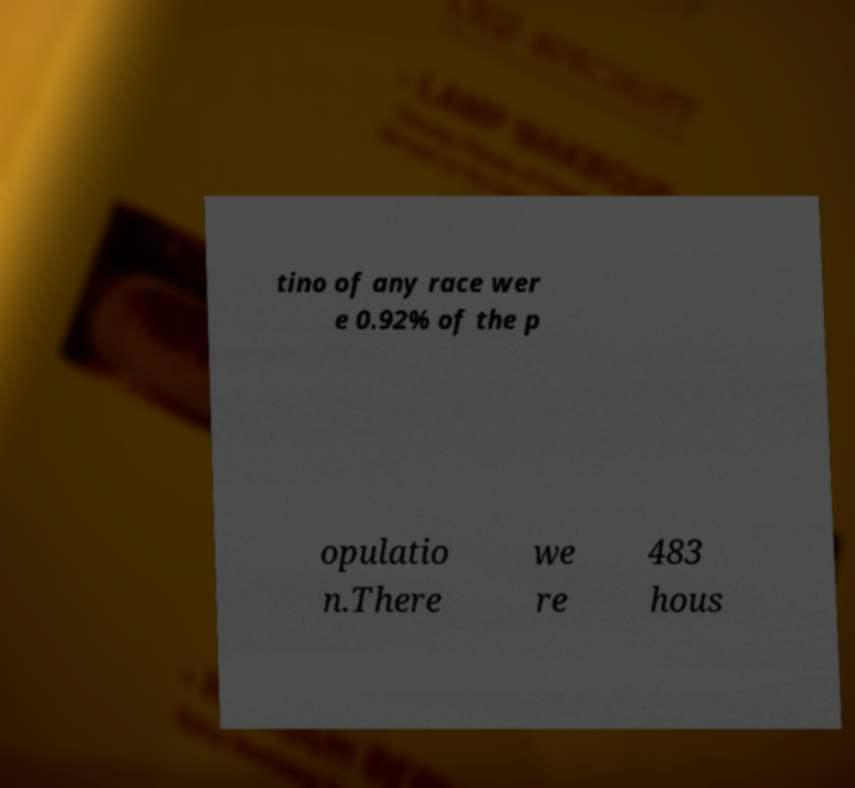Can you accurately transcribe the text from the provided image for me? tino of any race wer e 0.92% of the p opulatio n.There we re 483 hous 